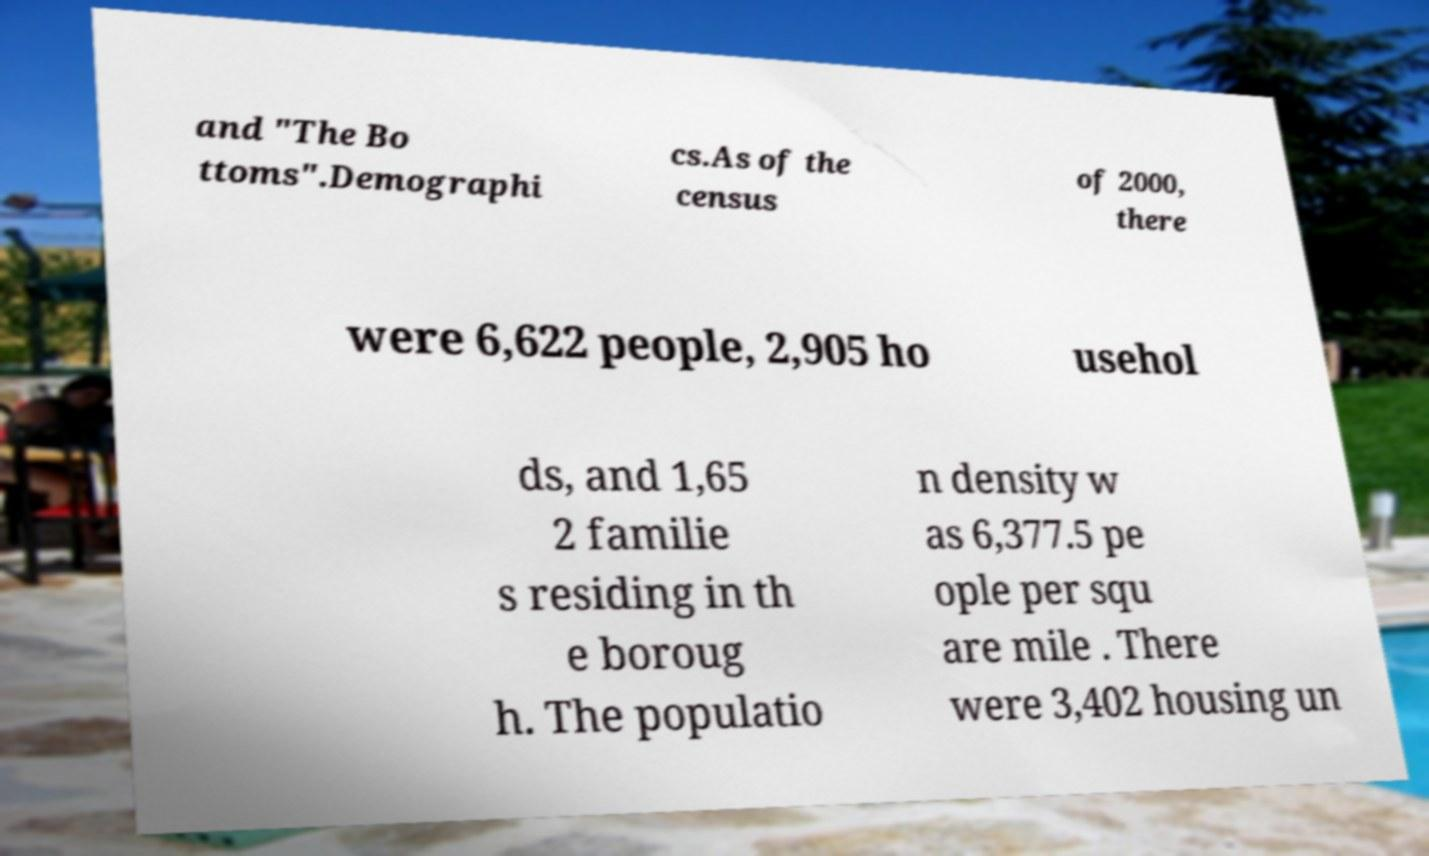Could you extract and type out the text from this image? and "The Bo ttoms".Demographi cs.As of the census of 2000, there were 6,622 people, 2,905 ho usehol ds, and 1,65 2 familie s residing in th e boroug h. The populatio n density w as 6,377.5 pe ople per squ are mile . There were 3,402 housing un 